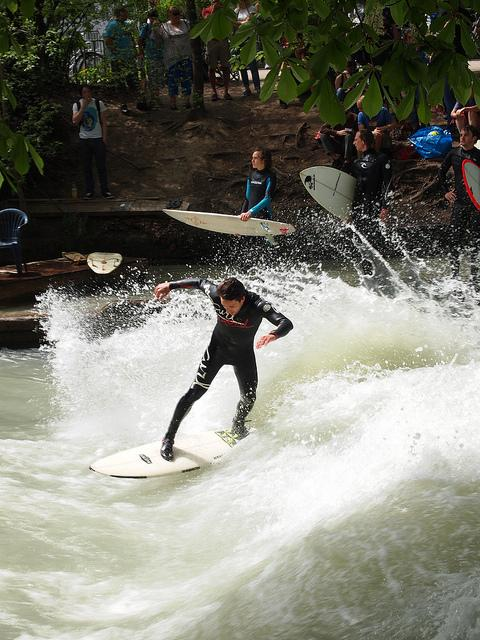Why is he standing like that?

Choices:
A) falling
B) tired
C) slipping
D) maintain balance maintain balance 